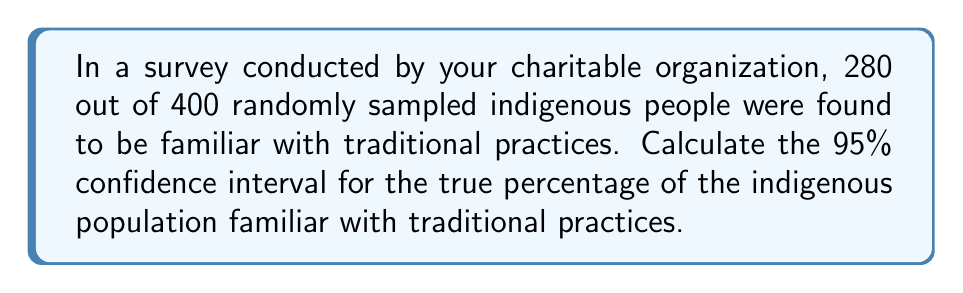Provide a solution to this math problem. Let's approach this step-by-step:

1. Identify the given information:
   - Sample size: $n = 400$
   - Number of successes: $x = 280$
   - Confidence level: 95% (z-score = 1.96)

2. Calculate the sample proportion:
   $\hat{p} = \frac{x}{n} = \frac{280}{400} = 0.7$

3. Calculate the standard error:
   $SE = \sqrt{\frac{\hat{p}(1-\hat{p})}{n}} = \sqrt{\frac{0.7(1-0.7)}{400}} = \sqrt{\frac{0.21}{400}} = 0.0229$

4. Determine the margin of error:
   $ME = z \times SE = 1.96 \times 0.0229 = 0.0449$

5. Calculate the confidence interval:
   Lower bound: $\hat{p} - ME = 0.7 - 0.0449 = 0.6551$
   Upper bound: $\hat{p} + ME = 0.7 + 0.0449 = 0.7449$

6. Convert to percentages:
   Lower bound: $0.6551 \times 100\% = 65.51\%$
   Upper bound: $0.7449 \times 100\% = 74.49\%$

Therefore, we can be 95% confident that the true percentage of the indigenous population familiar with traditional practices falls between 65.51% and 74.49%.
Answer: (65.51%, 74.49%) 